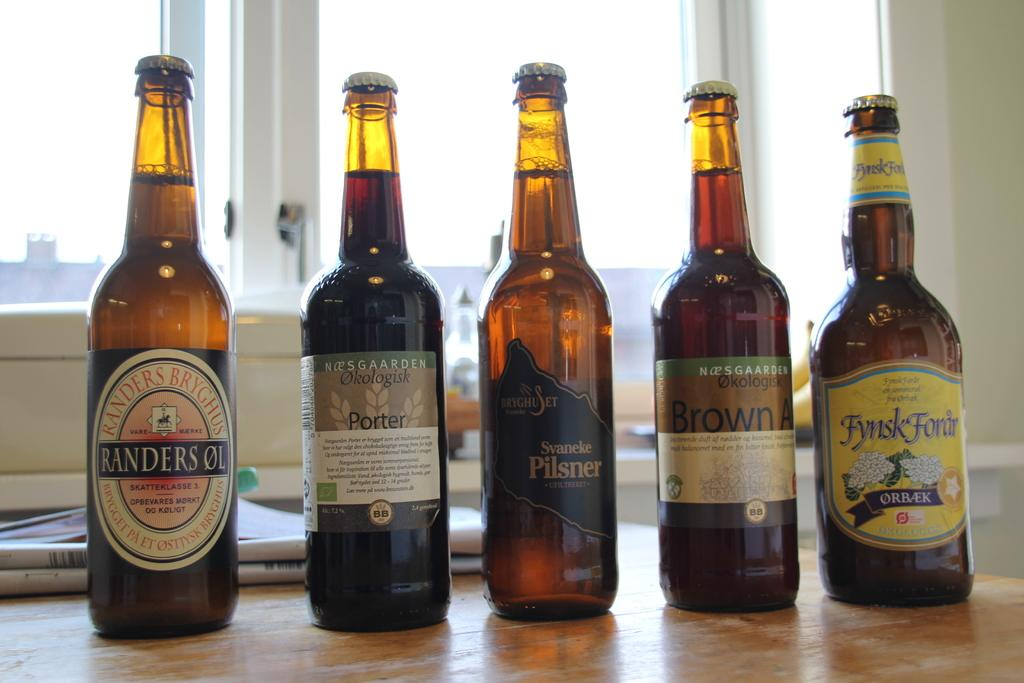What object is on the table in the image? There is a bottle on the table in the image. What other item is on the table besides the bottle? There is paper on the table. What can be seen in the background of the image? There is a glass window and a wall in the background. Where is the tramp located in the image? There is no tramp present in the image. Can you tell me where the faucet is in the image? There is no faucet present in the image. 